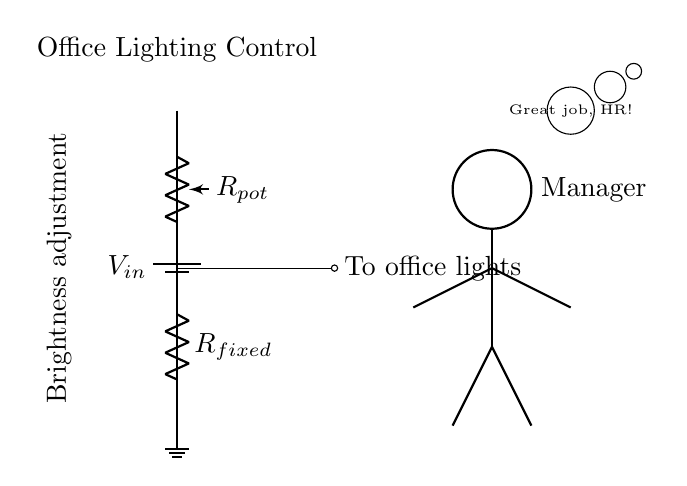What is the input voltage of the circuit? The input voltage is represented as V_in in the circuit diagram, indicating the voltage supplied to the circuit.
Answer: V_in What component is used for adjusting brightness? The potentiometer labeled R_pot in the diagram is the component used for adjusting the brightness of the office lights.
Answer: R_pot How many resistors are present in this circuit? The circuit contains two resistors: one potentiometer (R_pot) and one fixed resistor (R_fixed).
Answer: Two What does the fixed resistor do in this circuit? The fixed resistor (R_fixed) helps to set a minimum resistance level in the voltage divider, ensuring that some voltage is always sent to the lights, regardless of the setting of the potentiometer.
Answer: Sets minimum resistance If the potentiometer is fully turned, what happens to the voltage at the office lights? If the potentiometer is fully turned, the resistance of R_pot decreases, allowing maximum voltage from the input to reach the office lights, brightening them to full intensity.
Answer: Maximum voltage to lights What type of circuit is depicted in the diagram? The circuit is a voltage divider circuit, which adjusts the output voltage based on the resistance values of the components involved.
Answer: Voltage divider circuit 